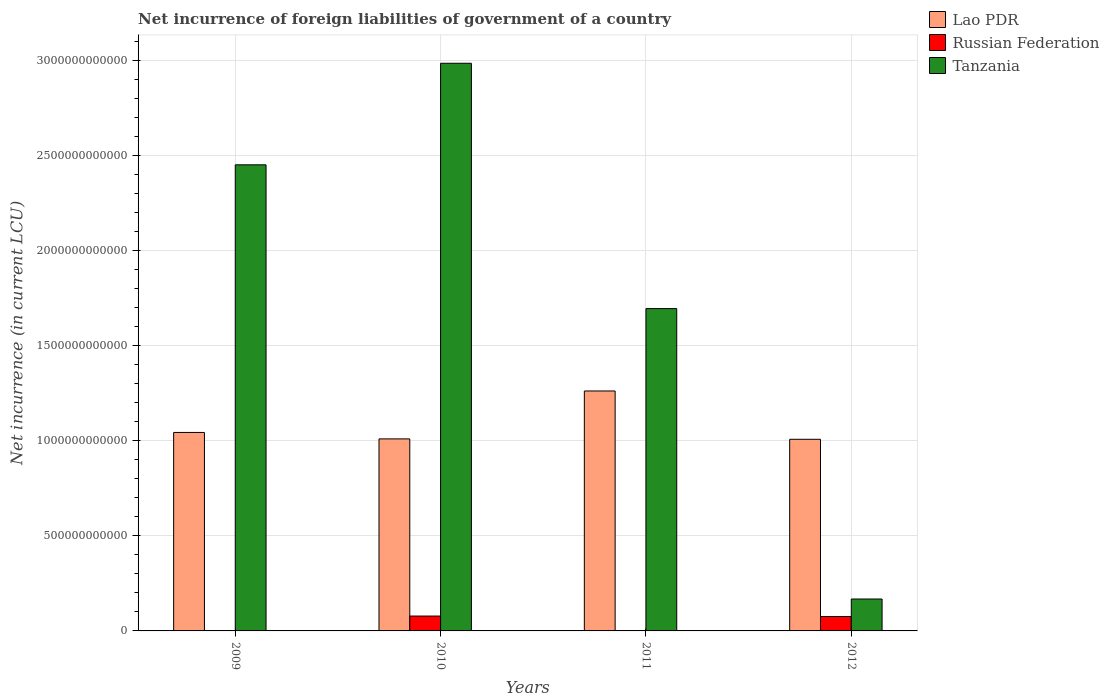How many bars are there on the 1st tick from the left?
Offer a very short reply. 2. How many bars are there on the 4th tick from the right?
Provide a succinct answer. 2. What is the net incurrence of foreign liabilities in Tanzania in 2012?
Your response must be concise. 1.68e+11. Across all years, what is the maximum net incurrence of foreign liabilities in Russian Federation?
Keep it short and to the point. 7.82e+1. In which year was the net incurrence of foreign liabilities in Russian Federation maximum?
Provide a succinct answer. 2010. What is the total net incurrence of foreign liabilities in Lao PDR in the graph?
Your answer should be compact. 4.32e+12. What is the difference between the net incurrence of foreign liabilities in Lao PDR in 2010 and that in 2011?
Offer a terse response. -2.52e+11. What is the difference between the net incurrence of foreign liabilities in Russian Federation in 2011 and the net incurrence of foreign liabilities in Lao PDR in 2009?
Ensure brevity in your answer.  -1.04e+12. What is the average net incurrence of foreign liabilities in Russian Federation per year?
Your answer should be very brief. 3.85e+1. In the year 2010, what is the difference between the net incurrence of foreign liabilities in Russian Federation and net incurrence of foreign liabilities in Lao PDR?
Offer a very short reply. -9.32e+11. What is the ratio of the net incurrence of foreign liabilities in Tanzania in 2009 to that in 2011?
Your response must be concise. 1.45. What is the difference between the highest and the second highest net incurrence of foreign liabilities in Lao PDR?
Provide a succinct answer. 2.18e+11. What is the difference between the highest and the lowest net incurrence of foreign liabilities in Tanzania?
Your answer should be compact. 2.82e+12. In how many years, is the net incurrence of foreign liabilities in Russian Federation greater than the average net incurrence of foreign liabilities in Russian Federation taken over all years?
Provide a succinct answer. 2. Is the sum of the net incurrence of foreign liabilities in Russian Federation in 2010 and 2012 greater than the maximum net incurrence of foreign liabilities in Tanzania across all years?
Your answer should be compact. No. How many bars are there?
Keep it short and to the point. 10. Are all the bars in the graph horizontal?
Offer a very short reply. No. How many years are there in the graph?
Ensure brevity in your answer.  4. What is the difference between two consecutive major ticks on the Y-axis?
Make the answer very short. 5.00e+11. How many legend labels are there?
Offer a terse response. 3. How are the legend labels stacked?
Make the answer very short. Vertical. What is the title of the graph?
Keep it short and to the point. Net incurrence of foreign liabilities of government of a country. Does "Vietnam" appear as one of the legend labels in the graph?
Your answer should be compact. No. What is the label or title of the X-axis?
Provide a short and direct response. Years. What is the label or title of the Y-axis?
Make the answer very short. Net incurrence (in current LCU). What is the Net incurrence (in current LCU) of Lao PDR in 2009?
Offer a terse response. 1.04e+12. What is the Net incurrence (in current LCU) in Tanzania in 2009?
Provide a short and direct response. 2.45e+12. What is the Net incurrence (in current LCU) in Lao PDR in 2010?
Ensure brevity in your answer.  1.01e+12. What is the Net incurrence (in current LCU) of Russian Federation in 2010?
Keep it short and to the point. 7.82e+1. What is the Net incurrence (in current LCU) of Tanzania in 2010?
Provide a succinct answer. 2.99e+12. What is the Net incurrence (in current LCU) in Lao PDR in 2011?
Your answer should be compact. 1.26e+12. What is the Net incurrence (in current LCU) of Tanzania in 2011?
Provide a short and direct response. 1.70e+12. What is the Net incurrence (in current LCU) of Lao PDR in 2012?
Offer a terse response. 1.01e+12. What is the Net incurrence (in current LCU) of Russian Federation in 2012?
Give a very brief answer. 7.58e+1. What is the Net incurrence (in current LCU) of Tanzania in 2012?
Offer a very short reply. 1.68e+11. Across all years, what is the maximum Net incurrence (in current LCU) of Lao PDR?
Give a very brief answer. 1.26e+12. Across all years, what is the maximum Net incurrence (in current LCU) of Russian Federation?
Offer a terse response. 7.82e+1. Across all years, what is the maximum Net incurrence (in current LCU) of Tanzania?
Your answer should be compact. 2.99e+12. Across all years, what is the minimum Net incurrence (in current LCU) of Lao PDR?
Offer a very short reply. 1.01e+12. Across all years, what is the minimum Net incurrence (in current LCU) of Tanzania?
Give a very brief answer. 1.68e+11. What is the total Net incurrence (in current LCU) of Lao PDR in the graph?
Make the answer very short. 4.32e+12. What is the total Net incurrence (in current LCU) in Russian Federation in the graph?
Ensure brevity in your answer.  1.54e+11. What is the total Net incurrence (in current LCU) of Tanzania in the graph?
Your response must be concise. 7.30e+12. What is the difference between the Net incurrence (in current LCU) in Lao PDR in 2009 and that in 2010?
Your response must be concise. 3.40e+1. What is the difference between the Net incurrence (in current LCU) in Tanzania in 2009 and that in 2010?
Your answer should be compact. -5.34e+11. What is the difference between the Net incurrence (in current LCU) in Lao PDR in 2009 and that in 2011?
Ensure brevity in your answer.  -2.18e+11. What is the difference between the Net incurrence (in current LCU) of Tanzania in 2009 and that in 2011?
Make the answer very short. 7.56e+11. What is the difference between the Net incurrence (in current LCU) in Lao PDR in 2009 and that in 2012?
Offer a terse response. 3.59e+1. What is the difference between the Net incurrence (in current LCU) of Tanzania in 2009 and that in 2012?
Your answer should be compact. 2.28e+12. What is the difference between the Net incurrence (in current LCU) of Lao PDR in 2010 and that in 2011?
Provide a succinct answer. -2.52e+11. What is the difference between the Net incurrence (in current LCU) in Tanzania in 2010 and that in 2011?
Provide a short and direct response. 1.29e+12. What is the difference between the Net incurrence (in current LCU) in Lao PDR in 2010 and that in 2012?
Ensure brevity in your answer.  1.97e+09. What is the difference between the Net incurrence (in current LCU) in Russian Federation in 2010 and that in 2012?
Ensure brevity in your answer.  2.40e+09. What is the difference between the Net incurrence (in current LCU) of Tanzania in 2010 and that in 2012?
Offer a very short reply. 2.82e+12. What is the difference between the Net incurrence (in current LCU) of Lao PDR in 2011 and that in 2012?
Keep it short and to the point. 2.54e+11. What is the difference between the Net incurrence (in current LCU) in Tanzania in 2011 and that in 2012?
Give a very brief answer. 1.53e+12. What is the difference between the Net incurrence (in current LCU) in Lao PDR in 2009 and the Net incurrence (in current LCU) in Russian Federation in 2010?
Provide a succinct answer. 9.66e+11. What is the difference between the Net incurrence (in current LCU) of Lao PDR in 2009 and the Net incurrence (in current LCU) of Tanzania in 2010?
Give a very brief answer. -1.94e+12. What is the difference between the Net incurrence (in current LCU) of Lao PDR in 2009 and the Net incurrence (in current LCU) of Tanzania in 2011?
Make the answer very short. -6.52e+11. What is the difference between the Net incurrence (in current LCU) of Lao PDR in 2009 and the Net incurrence (in current LCU) of Russian Federation in 2012?
Make the answer very short. 9.68e+11. What is the difference between the Net incurrence (in current LCU) of Lao PDR in 2009 and the Net incurrence (in current LCU) of Tanzania in 2012?
Your response must be concise. 8.76e+11. What is the difference between the Net incurrence (in current LCU) of Lao PDR in 2010 and the Net incurrence (in current LCU) of Tanzania in 2011?
Your answer should be compact. -6.86e+11. What is the difference between the Net incurrence (in current LCU) of Russian Federation in 2010 and the Net incurrence (in current LCU) of Tanzania in 2011?
Your response must be concise. -1.62e+12. What is the difference between the Net incurrence (in current LCU) in Lao PDR in 2010 and the Net incurrence (in current LCU) in Russian Federation in 2012?
Offer a very short reply. 9.34e+11. What is the difference between the Net incurrence (in current LCU) of Lao PDR in 2010 and the Net incurrence (in current LCU) of Tanzania in 2012?
Provide a succinct answer. 8.42e+11. What is the difference between the Net incurrence (in current LCU) of Russian Federation in 2010 and the Net incurrence (in current LCU) of Tanzania in 2012?
Offer a very short reply. -8.97e+1. What is the difference between the Net incurrence (in current LCU) of Lao PDR in 2011 and the Net incurrence (in current LCU) of Russian Federation in 2012?
Your answer should be very brief. 1.19e+12. What is the difference between the Net incurrence (in current LCU) of Lao PDR in 2011 and the Net incurrence (in current LCU) of Tanzania in 2012?
Your response must be concise. 1.09e+12. What is the average Net incurrence (in current LCU) in Lao PDR per year?
Give a very brief answer. 1.08e+12. What is the average Net incurrence (in current LCU) in Russian Federation per year?
Your response must be concise. 3.85e+1. What is the average Net incurrence (in current LCU) in Tanzania per year?
Make the answer very short. 1.83e+12. In the year 2009, what is the difference between the Net incurrence (in current LCU) of Lao PDR and Net incurrence (in current LCU) of Tanzania?
Give a very brief answer. -1.41e+12. In the year 2010, what is the difference between the Net incurrence (in current LCU) of Lao PDR and Net incurrence (in current LCU) of Russian Federation?
Your answer should be compact. 9.32e+11. In the year 2010, what is the difference between the Net incurrence (in current LCU) of Lao PDR and Net incurrence (in current LCU) of Tanzania?
Your response must be concise. -1.98e+12. In the year 2010, what is the difference between the Net incurrence (in current LCU) in Russian Federation and Net incurrence (in current LCU) in Tanzania?
Your answer should be compact. -2.91e+12. In the year 2011, what is the difference between the Net incurrence (in current LCU) of Lao PDR and Net incurrence (in current LCU) of Tanzania?
Keep it short and to the point. -4.33e+11. In the year 2012, what is the difference between the Net incurrence (in current LCU) in Lao PDR and Net incurrence (in current LCU) in Russian Federation?
Keep it short and to the point. 9.32e+11. In the year 2012, what is the difference between the Net incurrence (in current LCU) in Lao PDR and Net incurrence (in current LCU) in Tanzania?
Offer a terse response. 8.40e+11. In the year 2012, what is the difference between the Net incurrence (in current LCU) of Russian Federation and Net incurrence (in current LCU) of Tanzania?
Your answer should be very brief. -9.21e+1. What is the ratio of the Net incurrence (in current LCU) in Lao PDR in 2009 to that in 2010?
Offer a very short reply. 1.03. What is the ratio of the Net incurrence (in current LCU) in Tanzania in 2009 to that in 2010?
Your response must be concise. 0.82. What is the ratio of the Net incurrence (in current LCU) of Lao PDR in 2009 to that in 2011?
Provide a short and direct response. 0.83. What is the ratio of the Net incurrence (in current LCU) of Tanzania in 2009 to that in 2011?
Offer a terse response. 1.45. What is the ratio of the Net incurrence (in current LCU) of Lao PDR in 2009 to that in 2012?
Your response must be concise. 1.04. What is the ratio of the Net incurrence (in current LCU) of Tanzania in 2009 to that in 2012?
Your answer should be very brief. 14.6. What is the ratio of the Net incurrence (in current LCU) of Lao PDR in 2010 to that in 2011?
Your response must be concise. 0.8. What is the ratio of the Net incurrence (in current LCU) in Tanzania in 2010 to that in 2011?
Your answer should be compact. 1.76. What is the ratio of the Net incurrence (in current LCU) of Russian Federation in 2010 to that in 2012?
Offer a terse response. 1.03. What is the ratio of the Net incurrence (in current LCU) of Tanzania in 2010 to that in 2012?
Your answer should be very brief. 17.79. What is the ratio of the Net incurrence (in current LCU) in Lao PDR in 2011 to that in 2012?
Offer a very short reply. 1.25. What is the ratio of the Net incurrence (in current LCU) in Tanzania in 2011 to that in 2012?
Ensure brevity in your answer.  10.1. What is the difference between the highest and the second highest Net incurrence (in current LCU) in Lao PDR?
Offer a very short reply. 2.18e+11. What is the difference between the highest and the second highest Net incurrence (in current LCU) in Tanzania?
Provide a short and direct response. 5.34e+11. What is the difference between the highest and the lowest Net incurrence (in current LCU) of Lao PDR?
Offer a terse response. 2.54e+11. What is the difference between the highest and the lowest Net incurrence (in current LCU) in Russian Federation?
Ensure brevity in your answer.  7.82e+1. What is the difference between the highest and the lowest Net incurrence (in current LCU) of Tanzania?
Provide a short and direct response. 2.82e+12. 